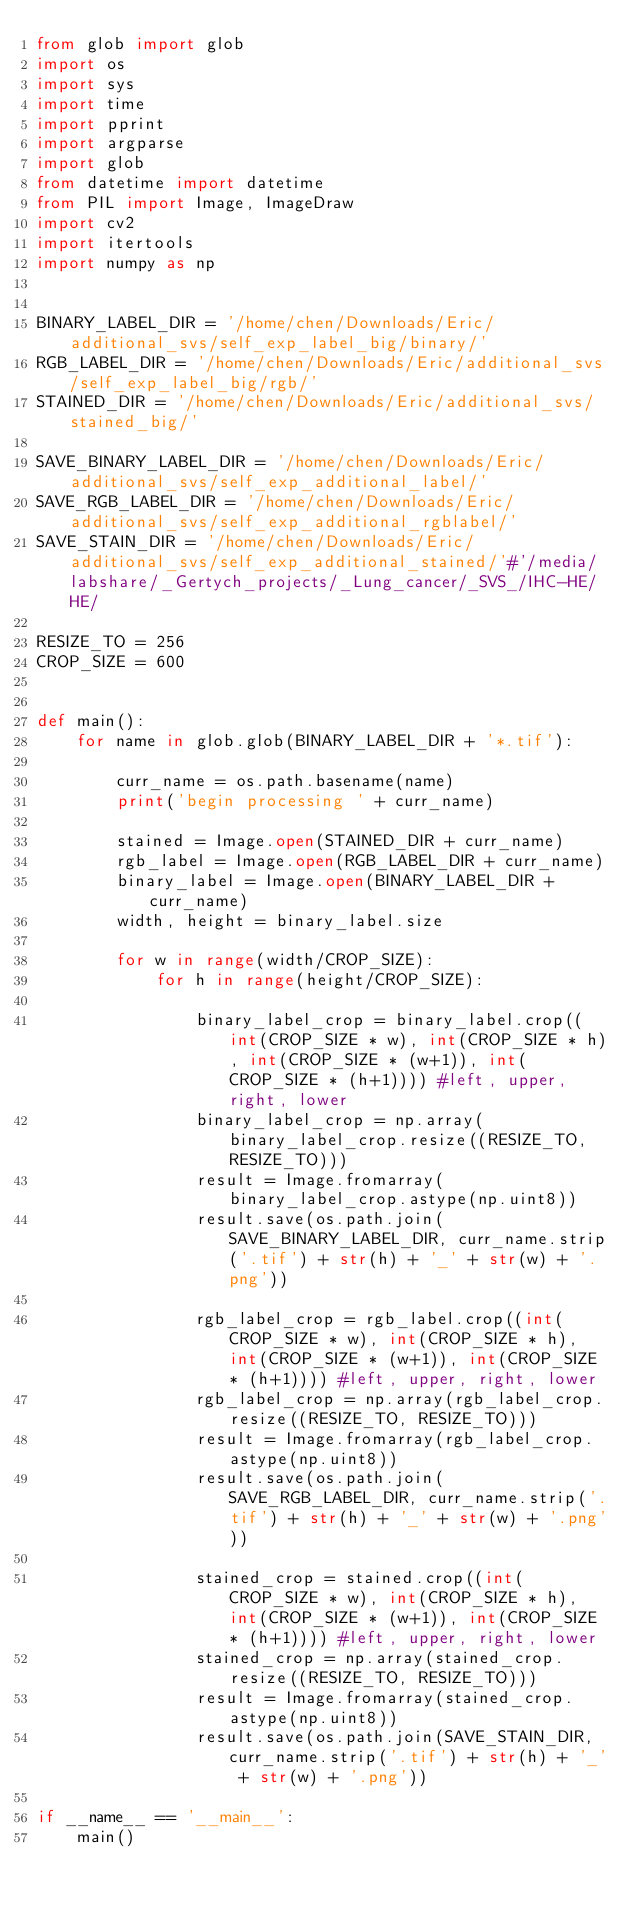<code> <loc_0><loc_0><loc_500><loc_500><_Python_>from glob import glob
import os
import sys
import time
import pprint
import argparse
import glob
from datetime import datetime
from PIL import Image, ImageDraw
import cv2
import itertools
import numpy as np


BINARY_LABEL_DIR = '/home/chen/Downloads/Eric/additional_svs/self_exp_label_big/binary/'
RGB_LABEL_DIR = '/home/chen/Downloads/Eric/additional_svs/self_exp_label_big/rgb/'
STAINED_DIR = '/home/chen/Downloads/Eric/additional_svs/stained_big/'

SAVE_BINARY_LABEL_DIR = '/home/chen/Downloads/Eric/additional_svs/self_exp_additional_label/'
SAVE_RGB_LABEL_DIR = '/home/chen/Downloads/Eric/additional_svs/self_exp_additional_rgblabel/'
SAVE_STAIN_DIR = '/home/chen/Downloads/Eric/additional_svs/self_exp_additional_stained/'#'/media/labshare/_Gertych_projects/_Lung_cancer/_SVS_/IHC-HE/HE/

RESIZE_TO = 256
CROP_SIZE = 600


def main():
	for name in glob.glob(BINARY_LABEL_DIR + '*.tif'):

		curr_name = os.path.basename(name) 
		print('begin processing ' + curr_name)

		stained = Image.open(STAINED_DIR + curr_name)
		rgb_label = Image.open(RGB_LABEL_DIR + curr_name)
		binary_label = Image.open(BINARY_LABEL_DIR + curr_name)
		width, height = binary_label.size

		for w in range(width/CROP_SIZE):
			for h in range(height/CROP_SIZE):

				binary_label_crop = binary_label.crop((int(CROP_SIZE * w), int(CROP_SIZE * h), int(CROP_SIZE * (w+1)), int(CROP_SIZE * (h+1)))) #left, upper, right, lower
				binary_label_crop = np.array(binary_label_crop.resize((RESIZE_TO, RESIZE_TO)))
				result = Image.fromarray(binary_label_crop.astype(np.uint8))
				result.save(os.path.join(SAVE_BINARY_LABEL_DIR, curr_name.strip('.tif') + str(h) + '_' + str(w) + '.png'))

				rgb_label_crop = rgb_label.crop((int(CROP_SIZE * w), int(CROP_SIZE * h), int(CROP_SIZE * (w+1)), int(CROP_SIZE * (h+1)))) #left, upper, right, lower
				rgb_label_crop = np.array(rgb_label_crop.resize((RESIZE_TO, RESIZE_TO)))
				result = Image.fromarray(rgb_label_crop.astype(np.uint8))
				result.save(os.path.join(SAVE_RGB_LABEL_DIR, curr_name.strip('.tif') + str(h) + '_' + str(w) + '.png'))

				stained_crop = stained.crop((int(CROP_SIZE * w), int(CROP_SIZE * h), int(CROP_SIZE * (w+1)), int(CROP_SIZE * (h+1)))) #left, upper, right, lower
				stained_crop = np.array(stained_crop.resize((RESIZE_TO, RESIZE_TO)))
				result = Image.fromarray(stained_crop.astype(np.uint8))
				result.save(os.path.join(SAVE_STAIN_DIR, curr_name.strip('.tif') + str(h) + '_' + str(w) + '.png'))
			
if __name__ == '__main__':
	main()</code> 